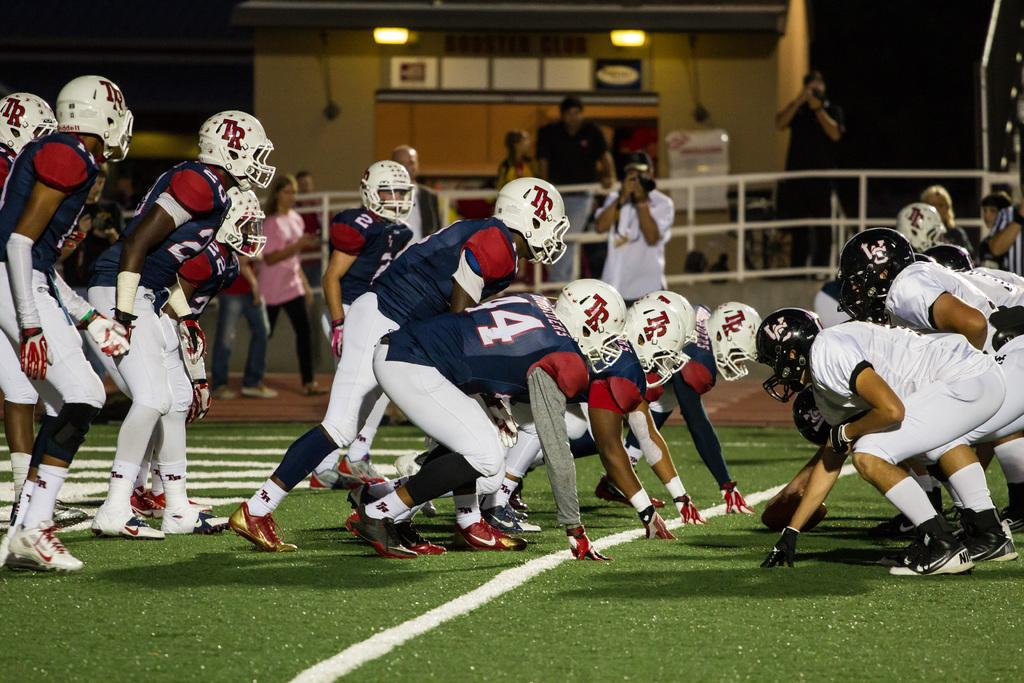What are the people in the image wearing on their heads? The people in the image are wearing helmets. What can be observed about the clothing of the people in the image? The people are wearing different color dresses. What can be seen in the background of the image? There is a building and lights visible in the background of the image. Are there any other people present in the image besides the ones wearing helmets? Yes, there are people standing in the background of the image. What type of bait is being used by the people in the image? There is no mention of bait or fishing in the image; the people are wearing helmets and standing near a building. 